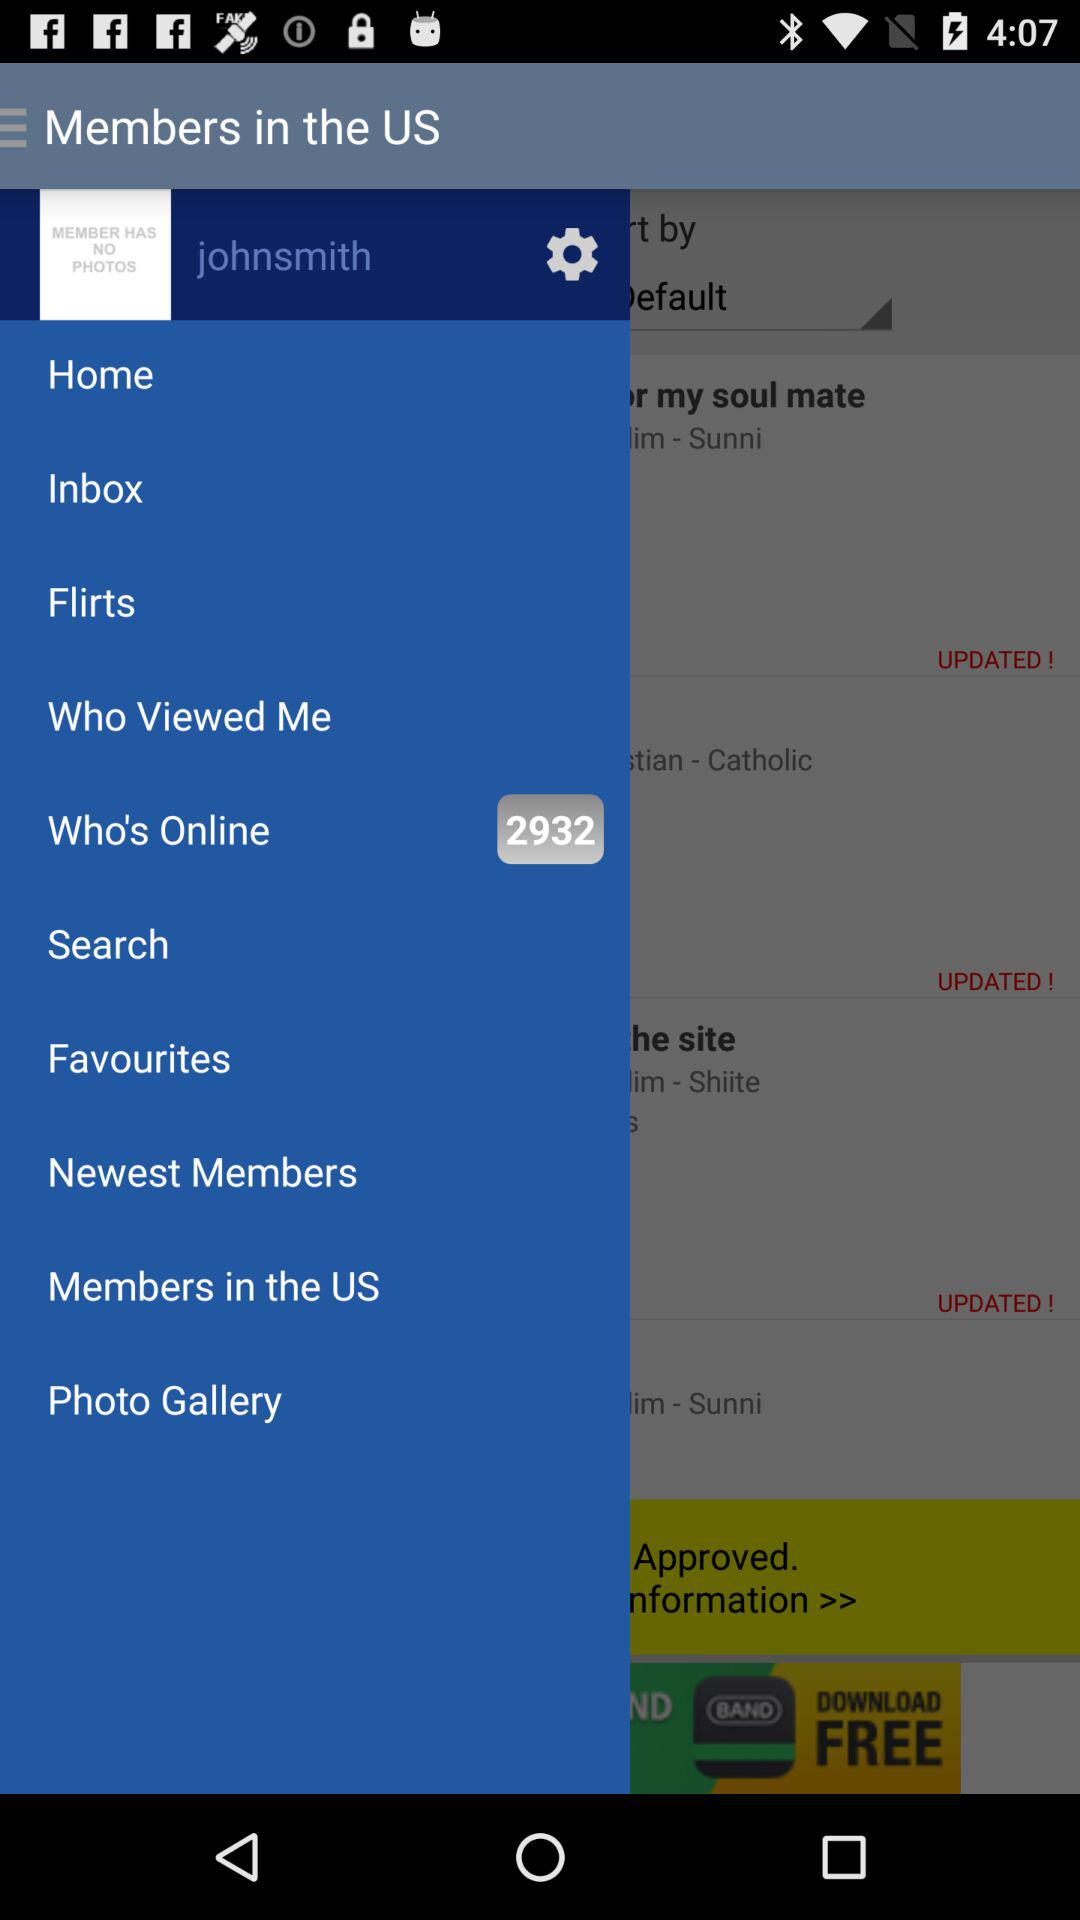What is the username? The username is "johnsmith". 